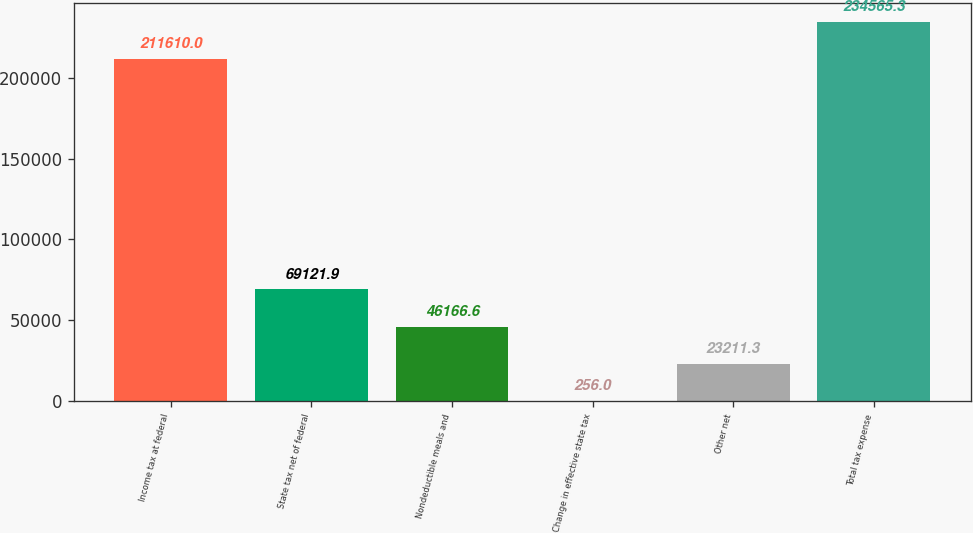Convert chart. <chart><loc_0><loc_0><loc_500><loc_500><bar_chart><fcel>Income tax at federal<fcel>State tax net of federal<fcel>Nondeductible meals and<fcel>Change in effective state tax<fcel>Other net<fcel>Total tax expense<nl><fcel>211610<fcel>69121.9<fcel>46166.6<fcel>256<fcel>23211.3<fcel>234565<nl></chart> 